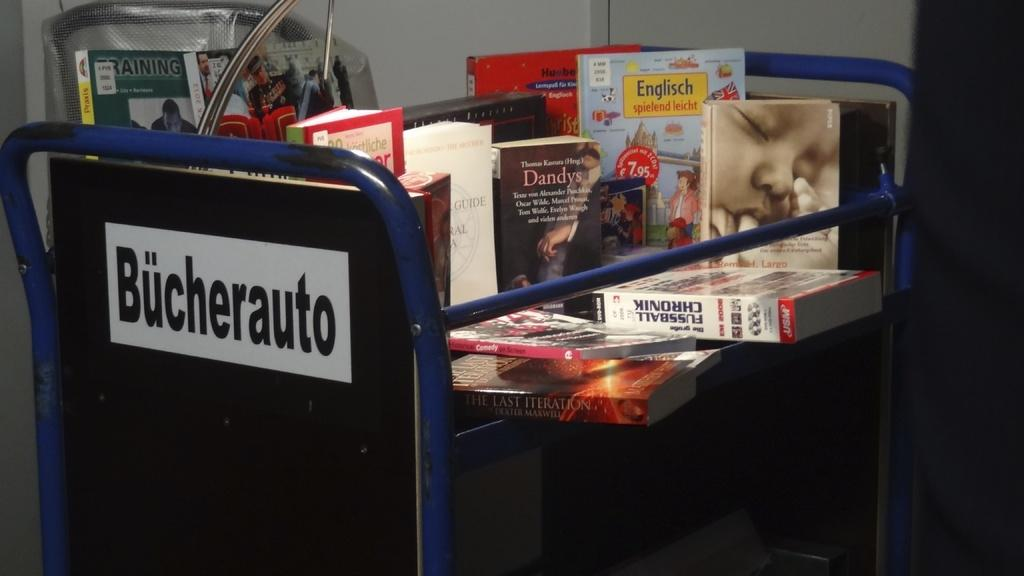<image>
Relay a brief, clear account of the picture shown. A blue cart has a stack of books including one called Dandys. 